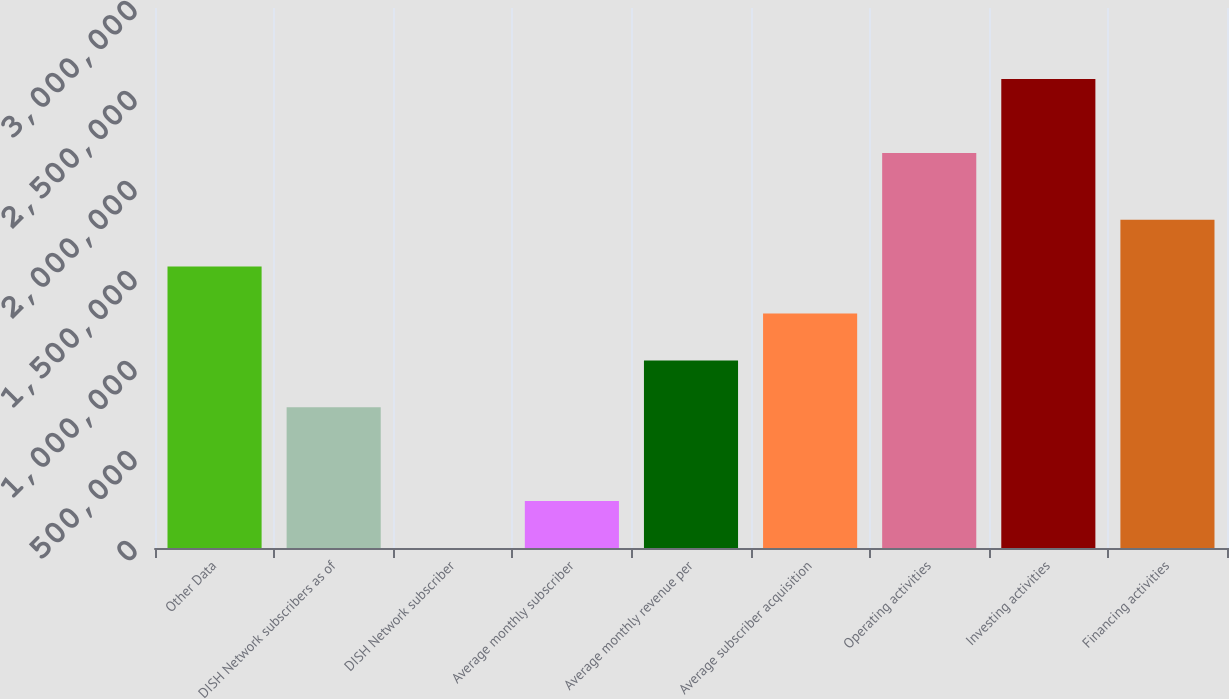<chart> <loc_0><loc_0><loc_500><loc_500><bar_chart><fcel>Other Data<fcel>DISH Network subscribers as of<fcel>DISH Network subscriber<fcel>Average monthly subscriber<fcel>Average monthly revenue per<fcel>Average subscriber acquisition<fcel>Operating activities<fcel>Investing activities<fcel>Financing activities<nl><fcel>1.56333e+06<fcel>781667<fcel>0.42<fcel>260556<fcel>1.04222e+06<fcel>1.30278e+06<fcel>2.19454e+06<fcel>2.60556e+06<fcel>1.82389e+06<nl></chart> 